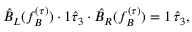<formula> <loc_0><loc_0><loc_500><loc_500>\hat { B } _ { L } ( f _ { B } ^ { ( \tau ) } ) \cdot 1 \hat { \tau } _ { 3 } \cdot \hat { B } _ { R } ( f _ { B } ^ { ( \tau ) } ) = 1 \, \hat { \tau } _ { 3 } ,</formula> 